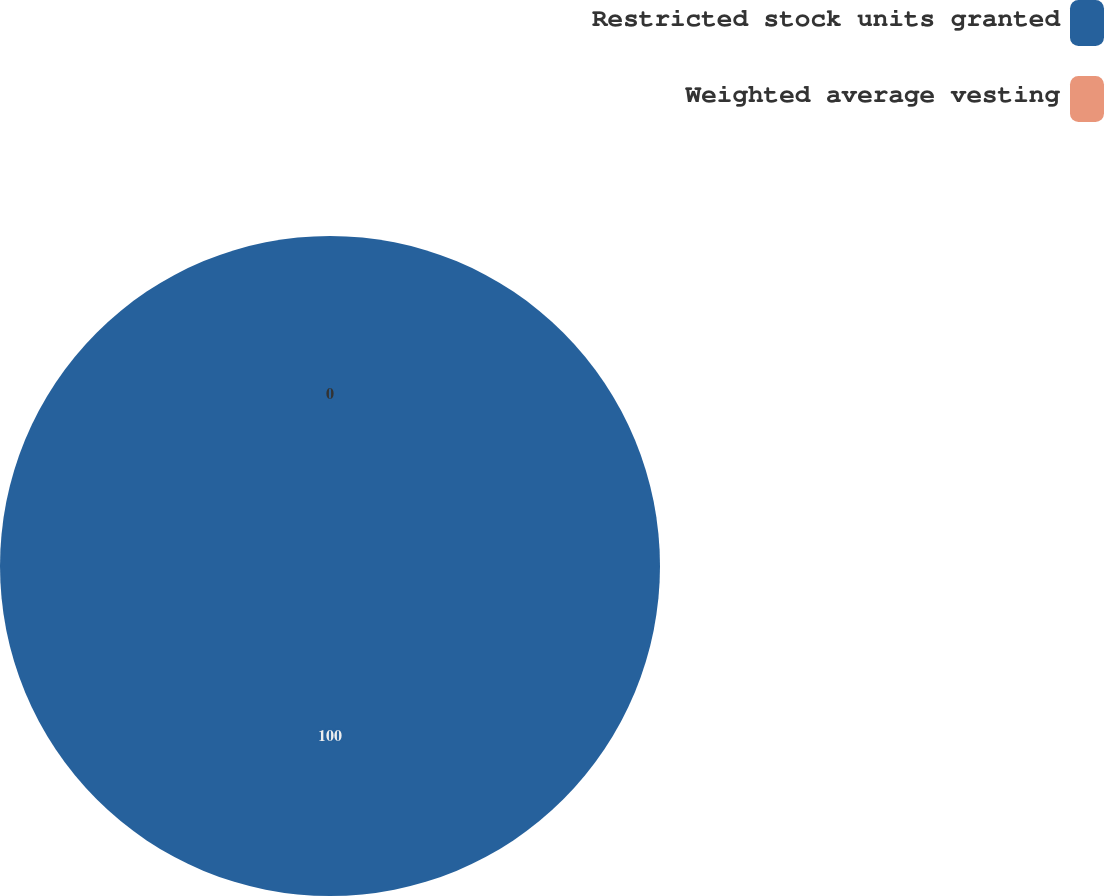<chart> <loc_0><loc_0><loc_500><loc_500><pie_chart><fcel>Restricted stock units granted<fcel>Weighted average vesting<nl><fcel>100.0%<fcel>0.0%<nl></chart> 